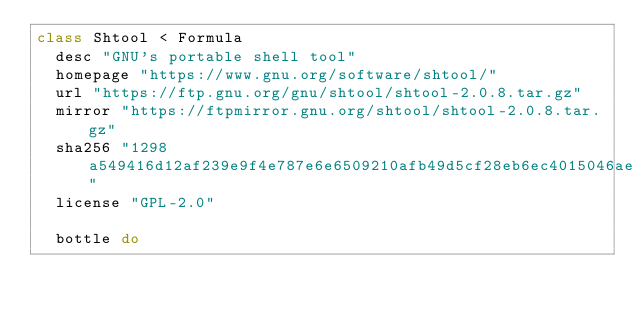<code> <loc_0><loc_0><loc_500><loc_500><_Ruby_>class Shtool < Formula
  desc "GNU's portable shell tool"
  homepage "https://www.gnu.org/software/shtool/"
  url "https://ftp.gnu.org/gnu/shtool/shtool-2.0.8.tar.gz"
  mirror "https://ftpmirror.gnu.org/shtool/shtool-2.0.8.tar.gz"
  sha256 "1298a549416d12af239e9f4e787e6e6509210afb49d5cf28eb6ec4015046ae19"
  license "GPL-2.0"

  bottle do</code> 